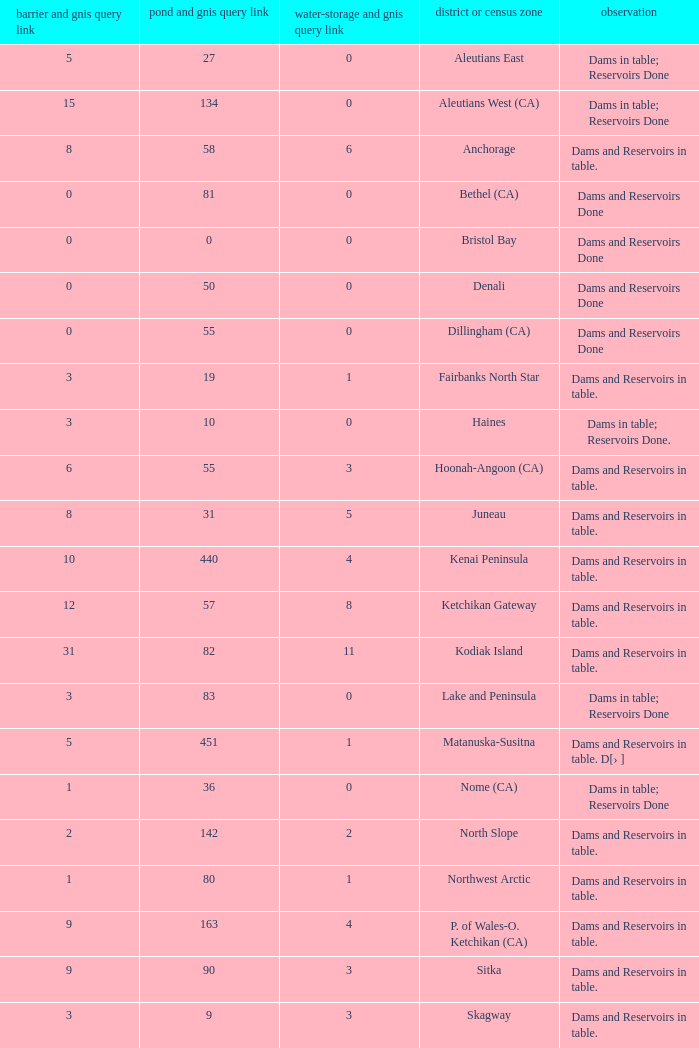Name the most numbers dam and gnis query link for borough or census area for fairbanks north star 3.0. 